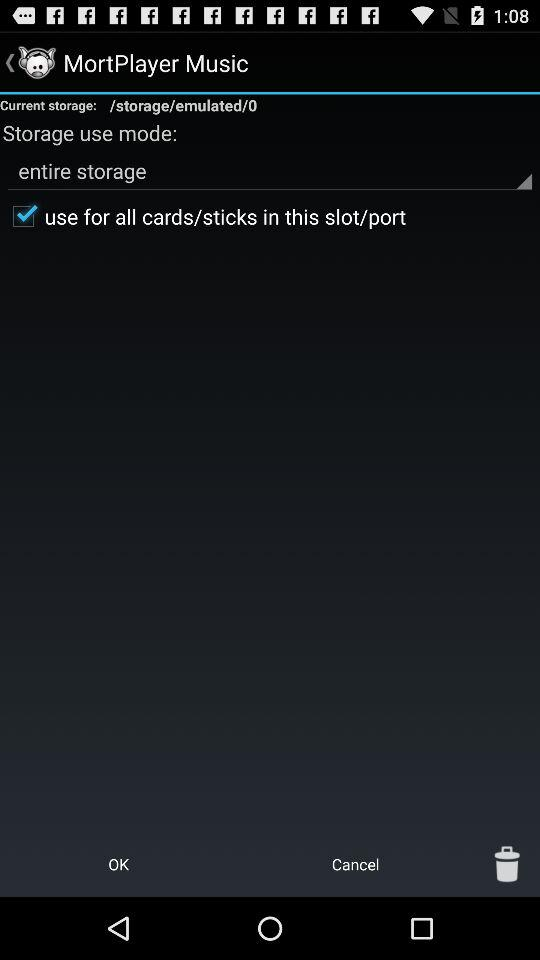How many storage options are available?
Answer the question using a single word or phrase. 2 